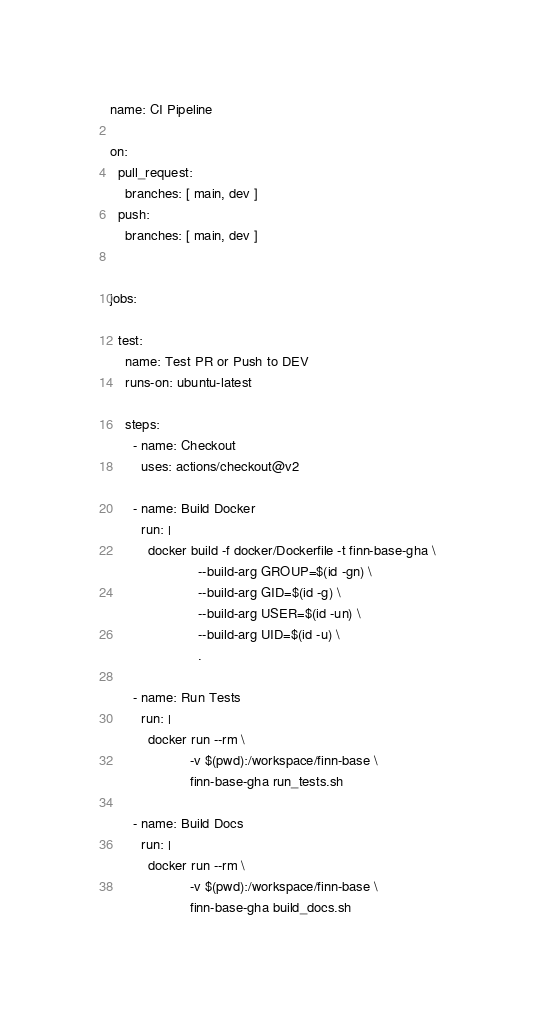<code> <loc_0><loc_0><loc_500><loc_500><_YAML_>name: CI Pipeline

on:
  pull_request:
    branches: [ main, dev ]
  push:
    branches: [ main, dev ]


jobs:

  test:
    name: Test PR or Push to DEV
    runs-on: ubuntu-latest

    steps:
      - name: Checkout
        uses: actions/checkout@v2

      - name: Build Docker
        run: |
          docker build -f docker/Dockerfile -t finn-base-gha \
                       --build-arg GROUP=$(id -gn) \
                       --build-arg GID=$(id -g) \
                       --build-arg USER=$(id -un) \
                       --build-arg UID=$(id -u) \
                       .

      - name: Run Tests
        run: |
          docker run --rm \
                     -v $(pwd):/workspace/finn-base \
                     finn-base-gha run_tests.sh

      - name: Build Docs
        run: |
          docker run --rm \
                     -v $(pwd):/workspace/finn-base \
                     finn-base-gha build_docs.sh
</code> 